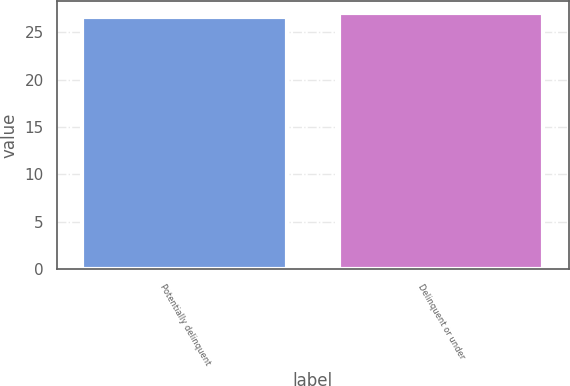Convert chart. <chart><loc_0><loc_0><loc_500><loc_500><bar_chart><fcel>Potentially delinquent<fcel>Delinquent or under<nl><fcel>26.6<fcel>27<nl></chart> 